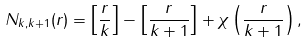<formula> <loc_0><loc_0><loc_500><loc_500>N _ { k , k + 1 } ( r ) = \left [ \frac { r } { k } \right ] - \left [ \frac { r } { k + 1 } \right ] + \chi \left ( \frac { r } { k + 1 } \right ) ,</formula> 